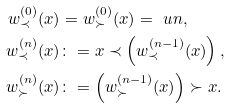Convert formula to latex. <formula><loc_0><loc_0><loc_500><loc_500>w ^ { ( 0 ) } _ { \prec } ( x ) & = w ^ { ( 0 ) } _ { \succ } ( x ) = \ u n , \\ w ^ { ( n ) } _ { \prec } ( x ) & \colon = x \prec \left ( w ^ { ( n - 1 ) } _ { \prec } ( x ) \right ) , \\ w ^ { ( n ) } _ { \succ } ( x ) & \colon = \left ( w ^ { ( n - 1 ) } _ { \succ } ( x ) \right ) \succ x .</formula> 